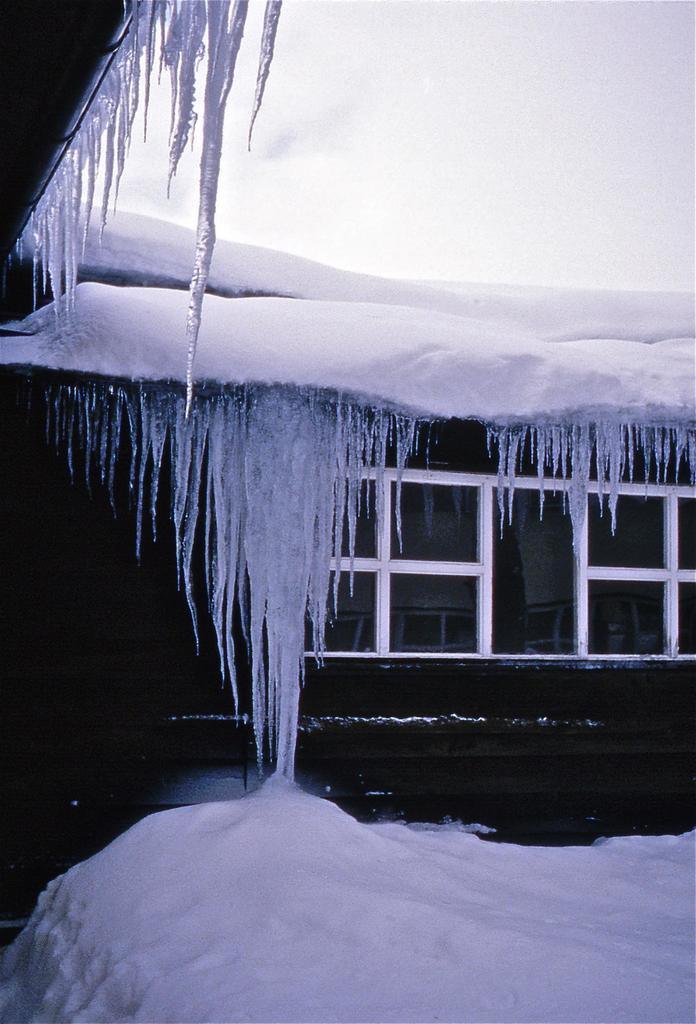Could you give a brief overview of what you see in this image? Here we can see snow and windows. In the background there is sky. 